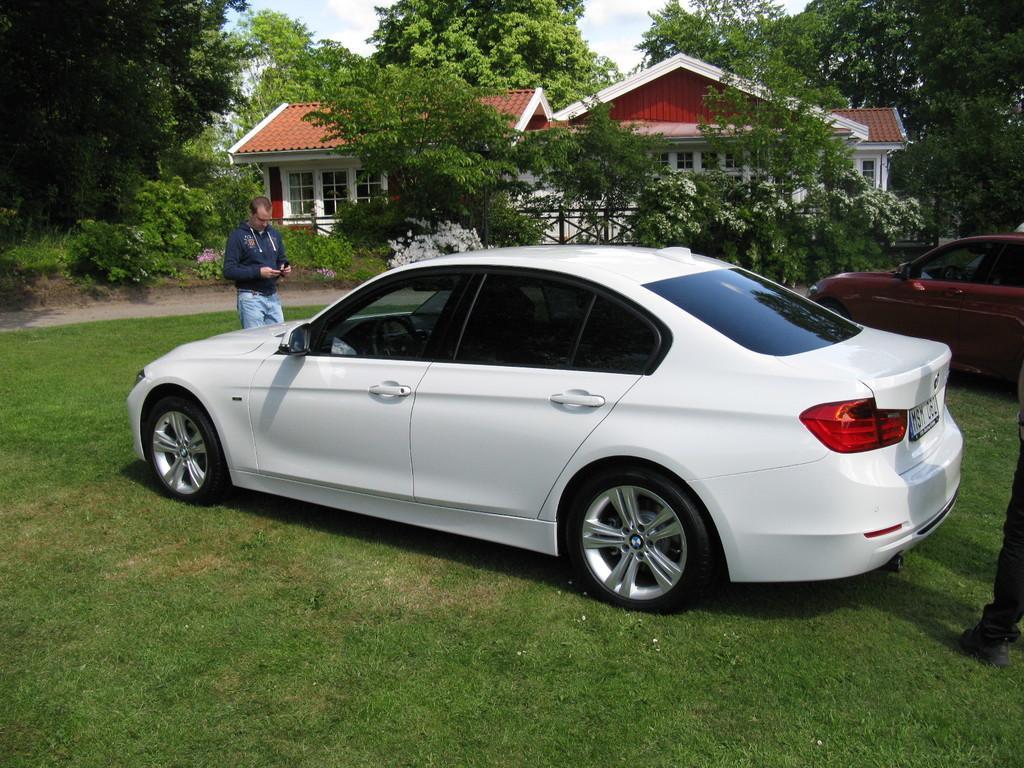Can you describe this image briefly? In the picture we can see a grass surface on it we can see a car which is white in color and in front of the car we can see a man standing and behind the car also we can see a person standing and beside it we can see another car which is red in color and in the background we can see some plants, railing, house with windows and behind the house we can see trees and sky with clouds. 